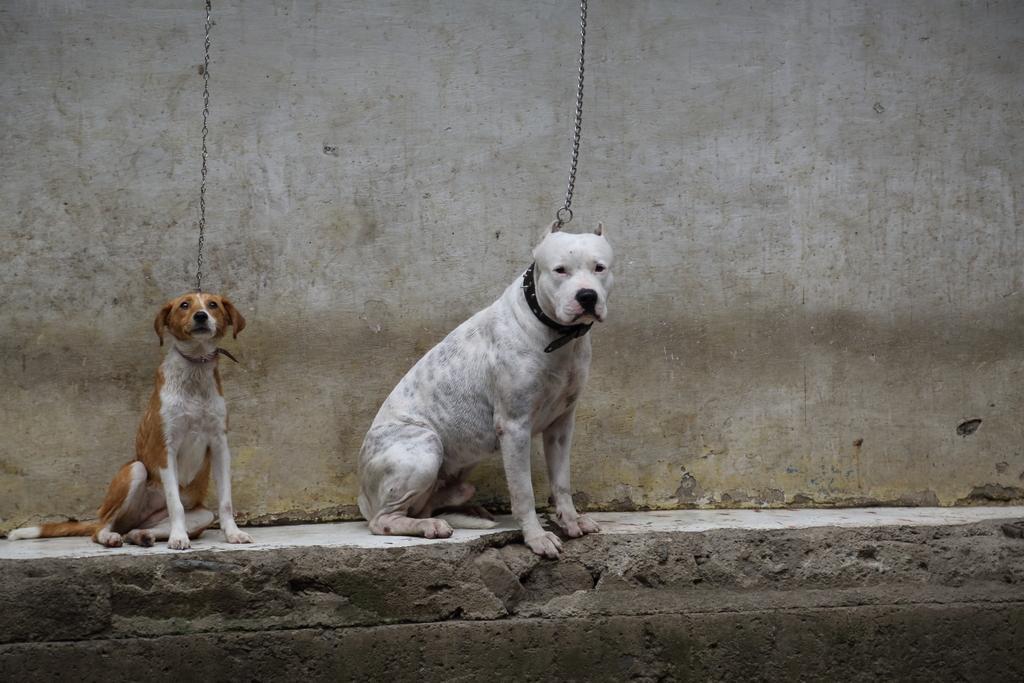Can you describe this image briefly? In this picture we can see two dogs sitting on a platform, chains and in the background we can see wall. 